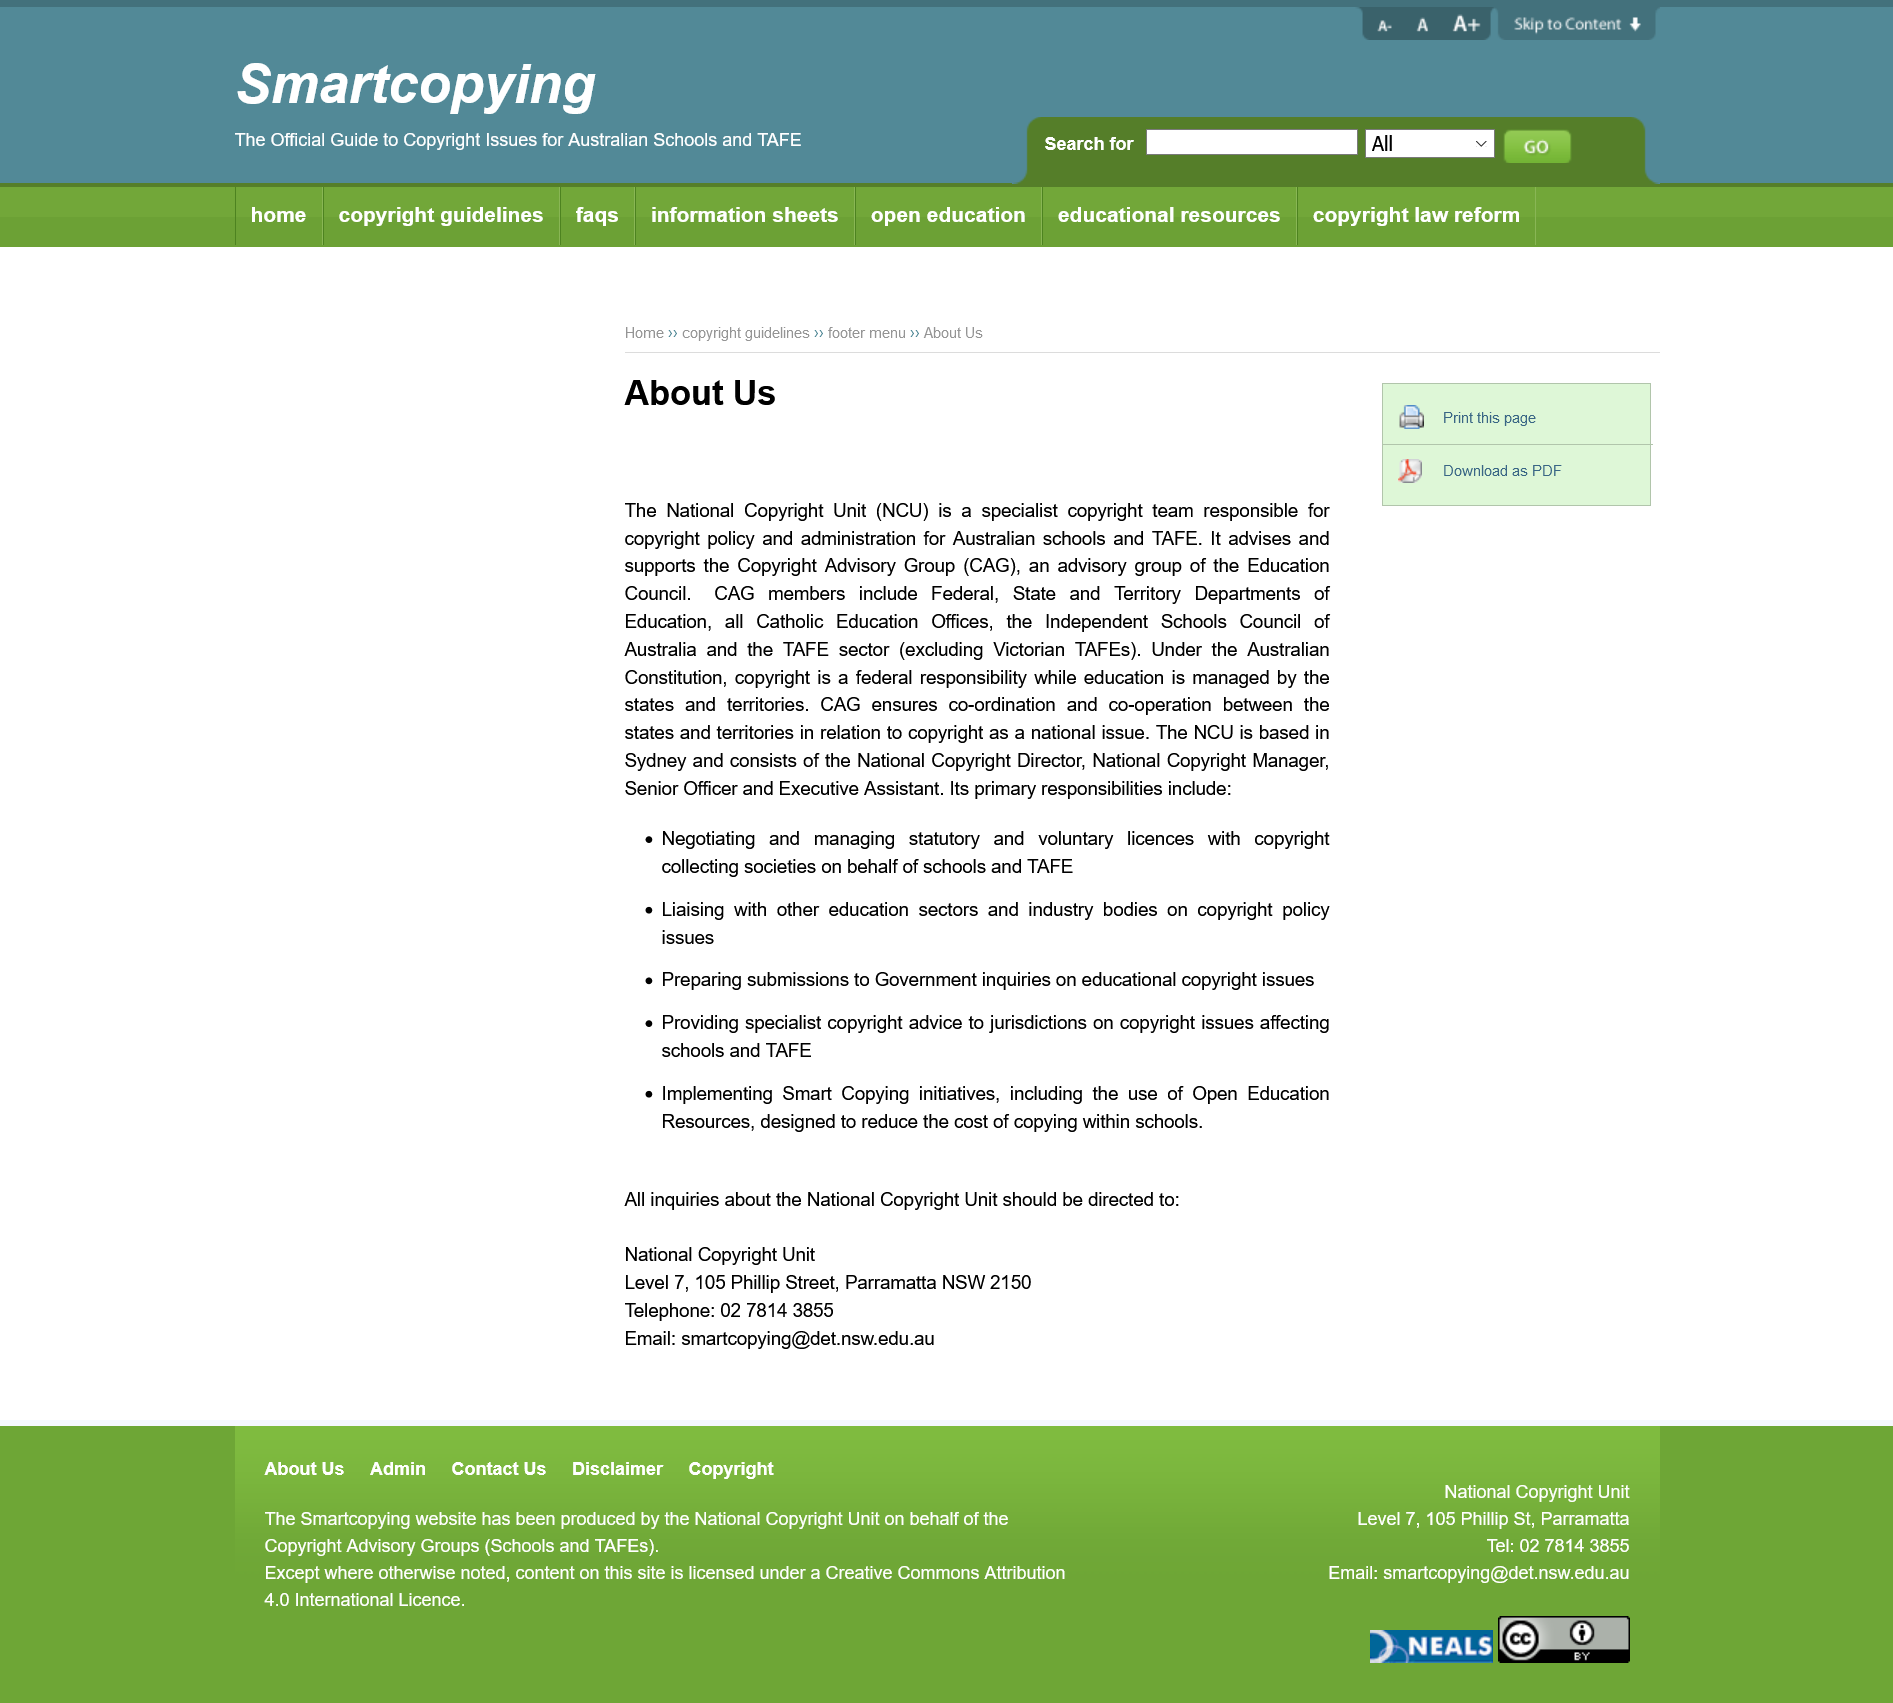Give some essential details in this illustration. The Copyright Advisory Group (CAG) is advised and supported by Who Advises and Supports. Who Advises and Supports is an advisory group of the Education Council. The National Copyright Unit (NCU) is a specialized team that handles copyright policy and administration specifically for Australian schools and TAFE institutions. Under the Australian Constitution, copyright is a federal responsibility, and it is the responsibility of those who hold copyright to ensure that their rights are protected. 